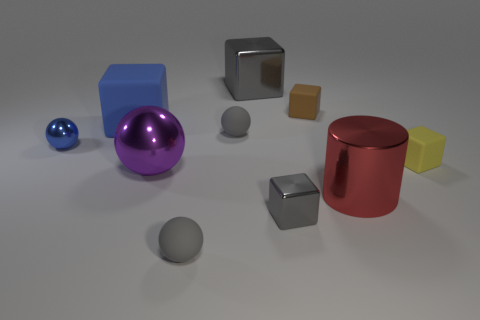Are there any other things that have the same shape as the big red object?
Offer a terse response. No. What is the color of the big thing that is the same material as the brown cube?
Provide a short and direct response. Blue. What size is the rubber object that is in front of the tiny blue metallic thing and left of the red object?
Give a very brief answer. Small. Is the number of large blocks that are on the left side of the large metallic block less than the number of small blue things that are left of the small blue metal thing?
Provide a short and direct response. No. Is the gray sphere that is in front of the red shiny object made of the same material as the gray cube that is behind the blue rubber cube?
Give a very brief answer. No. There is a object that is the same color as the big matte block; what is its material?
Provide a short and direct response. Metal. The big thing that is both on the right side of the blue rubber thing and behind the yellow rubber thing has what shape?
Your response must be concise. Cube. There is a small gray ball that is on the right side of the gray matte sphere in front of the tiny blue metal thing; what is it made of?
Keep it short and to the point. Rubber. Are there more tiny purple cylinders than cylinders?
Provide a short and direct response. No. Does the tiny metal ball have the same color as the metallic cylinder?
Offer a terse response. No. 